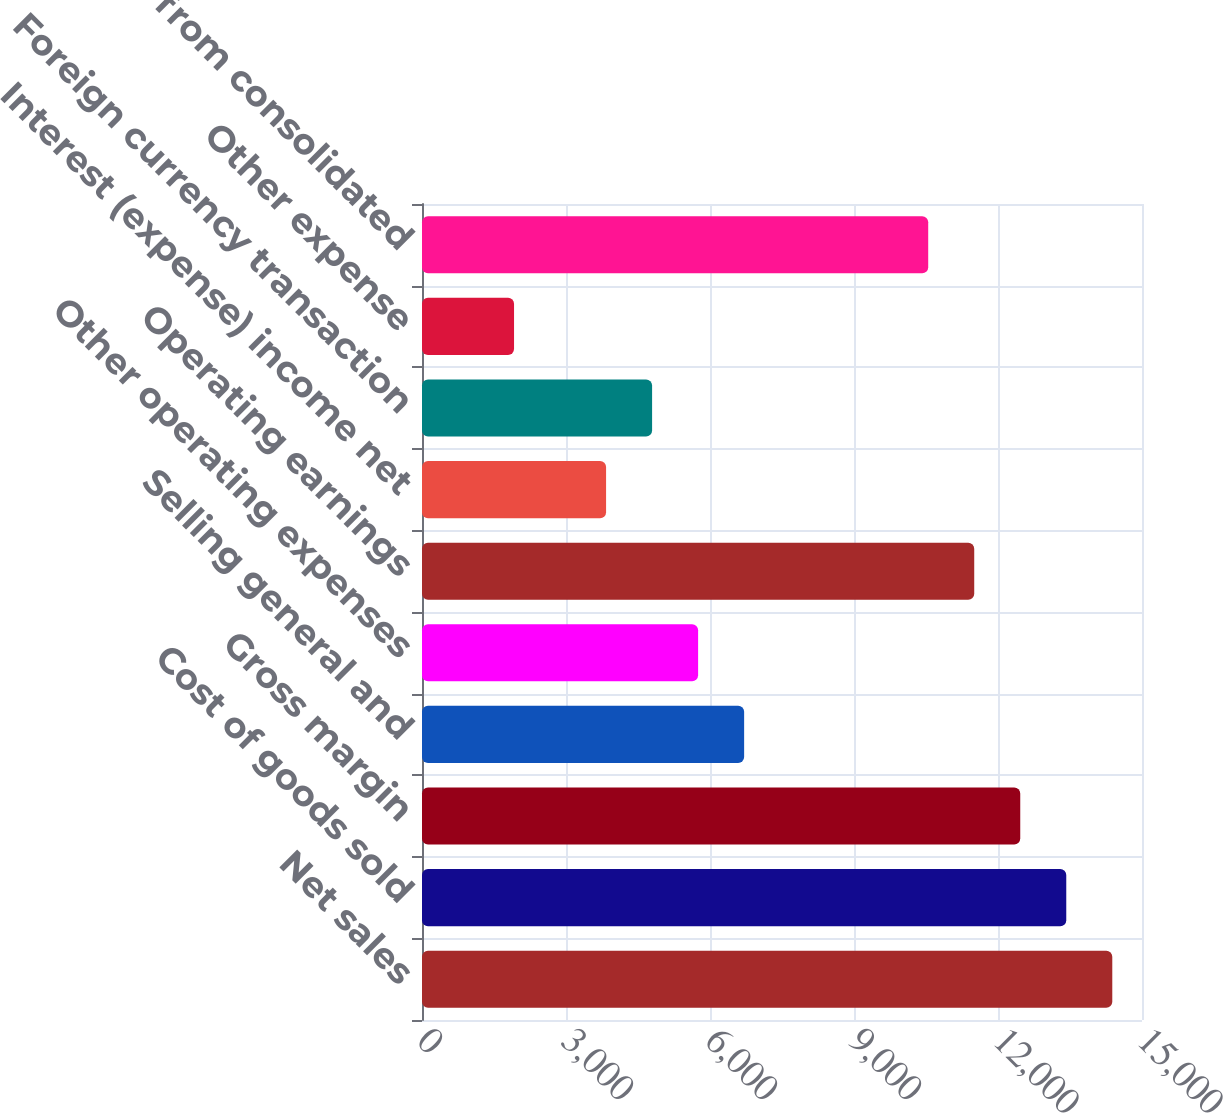Convert chart to OTSL. <chart><loc_0><loc_0><loc_500><loc_500><bar_chart><fcel>Net sales<fcel>Cost of goods sold<fcel>Gross margin<fcel>Selling general and<fcel>Other operating expenses<fcel>Operating earnings<fcel>Interest (expense) income net<fcel>Foreign currency transaction<fcel>Other expense<fcel>Earnings from consolidated<nl><fcel>14380.9<fcel>13422.2<fcel>12463.5<fcel>6711.14<fcel>5752.42<fcel>11504.7<fcel>3834.98<fcel>4793.7<fcel>1917.54<fcel>10546<nl></chart> 